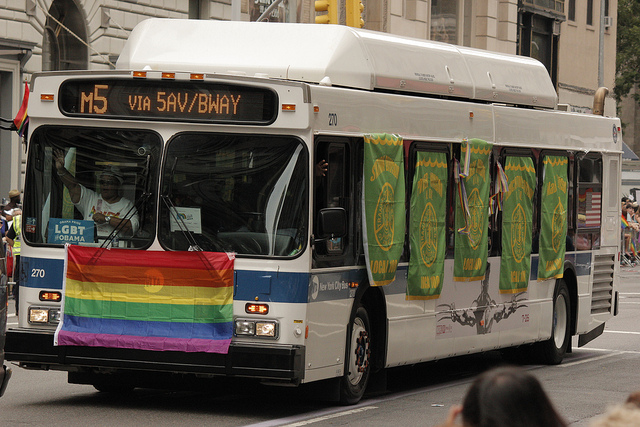<image>What country's flags are on the bus? I don't know what country's flags are on the bus. It could be Bahrain, Brazil, or even a rainbow or LGBT flag. What country's flags are on the bus? I am not sure what country's flags are on the bus. It can be seen 'bahrain' or 'brazil'. 